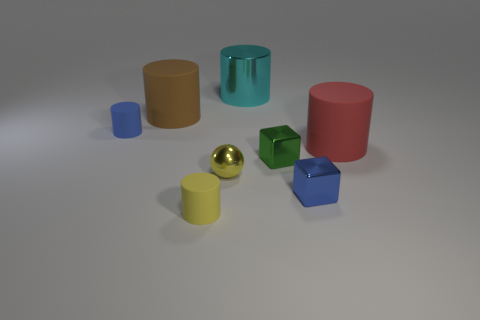There is a green object that is the same size as the blue cylinder; what is its shape?
Keep it short and to the point. Cube. Is the number of cubes greater than the number of rubber cylinders?
Offer a very short reply. No. There is a cylinder that is to the left of the tiny shiny sphere and in front of the blue rubber object; what is its material?
Make the answer very short. Rubber. How many other things are the same material as the small green cube?
Make the answer very short. 3. How many tiny shiny blocks are the same color as the metallic cylinder?
Offer a terse response. 0. How big is the cylinder in front of the yellow thing that is behind the small cylinder that is in front of the tiny blue matte cylinder?
Your response must be concise. Small. How many matte objects are blocks or small green cubes?
Provide a succinct answer. 0. There is a large cyan metal thing; is it the same shape as the tiny matte thing that is in front of the small yellow metal ball?
Offer a terse response. Yes. Is the number of green shiny blocks that are left of the big cyan cylinder greater than the number of shiny objects that are to the right of the yellow matte thing?
Make the answer very short. No. Is there anything else of the same color as the sphere?
Offer a terse response. Yes. 